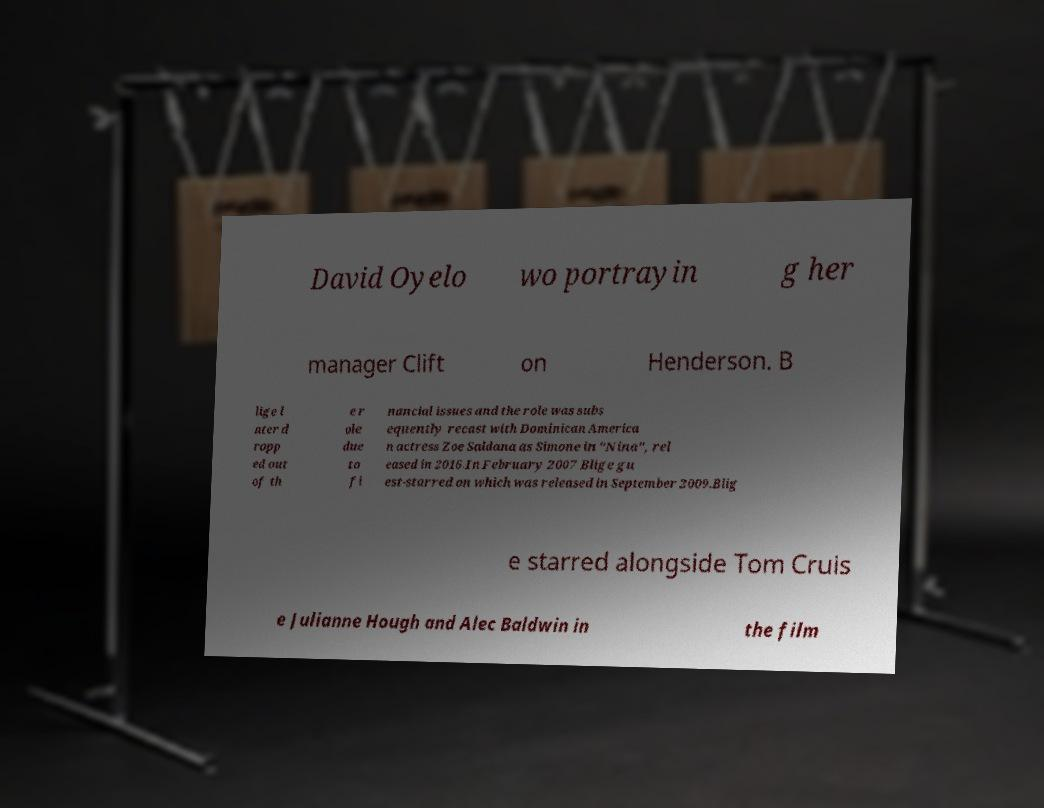Can you read and provide the text displayed in the image?This photo seems to have some interesting text. Can you extract and type it out for me? David Oyelo wo portrayin g her manager Clift on Henderson. B lige l ater d ropp ed out of th e r ole due to fi nancial issues and the role was subs equently recast with Dominican America n actress Zoe Saldana as Simone in "Nina", rel eased in 2016.In February 2007 Blige gu est-starred on which was released in September 2009.Blig e starred alongside Tom Cruis e Julianne Hough and Alec Baldwin in the film 